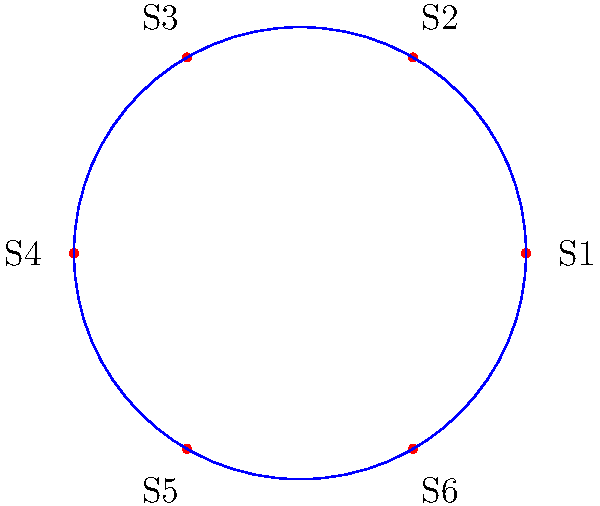In a circular spice market layout with 6 equally spaced stalls, each rotation of 60° clockwise represents a permutation of the stalls. How many unique permutations can be generated by repeated rotations, and what is the order of the resulting cyclic group? To solve this problem, we need to follow these steps:

1) First, we need to understand that each rotation of 60° clockwise represents a permutation of the stalls.

2) Let's label the permutation that represents a single 60° clockwise rotation as $r$. Then, the possible rotations are:
   - $r^0$ (identity, no rotation)
   - $r^1$ (60° rotation)
   - $r^2$ (120° rotation)
   - $r^3$ (180° rotation)
   - $r^4$ (240° rotation)
   - $r^5$ (300° rotation)

3) Notice that $r^6$ would be a full 360° rotation, which brings us back to the starting position. This means $r^6 = r^0$.

4) Each of these rotations ($r^0$ to $r^5$) produces a unique permutation of the stalls.

5) The number of unique permutations is therefore 6.

6) In group theory, this forms a cyclic group of order 6, denoted as $C_6$ or $\mathbb{Z}_6$.

7) The order of a group is the number of elements in the group, which in this case is 6.

Therefore, there are 6 unique permutations, and the resulting cyclic group has an order of 6.
Answer: 6 permutations; order 6 